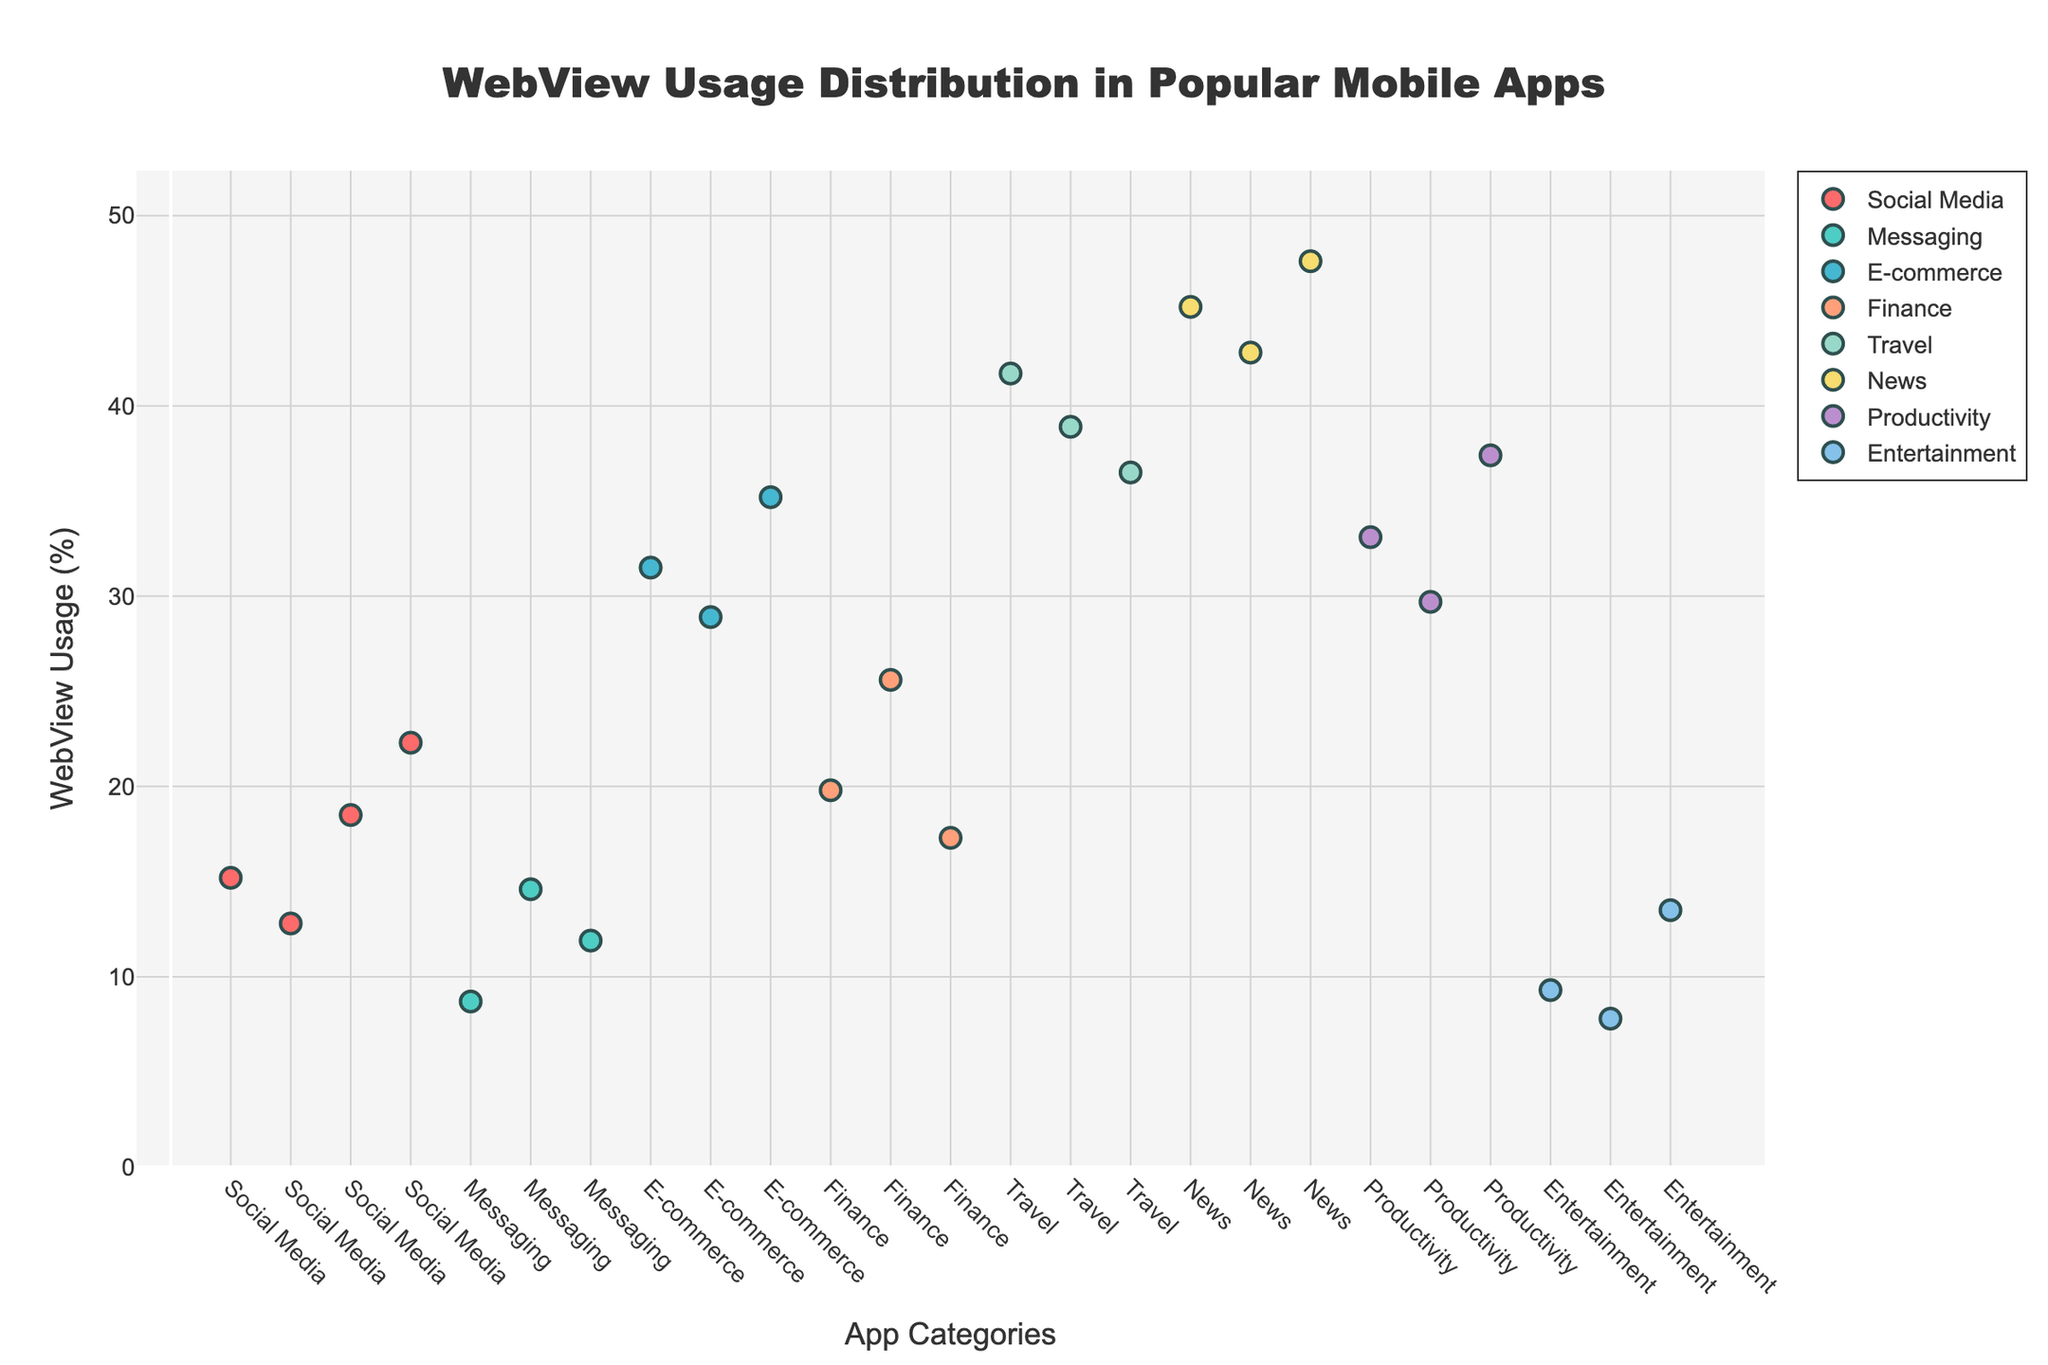What's the title of the plot? The title is usually displayed at the top of the plot. In this case, it reads "WebView Usage Distribution in Popular Mobile Apps".
Answer: WebView Usage Distribution in Popular Mobile Apps What is the y-axis representing? The y-axis represents "WebView Usage (%)", indicating the percentage of WebView usage among the apps. This can be deduced from the y-axis label.
Answer: WebView Usage (%) Which app has the highest WebView usage percentage? By observing the highest point on the y-axis, you can identify that "The New York Times" has the highest WebView usage percentage at 47.6%.
Answer: The New York Times How many app categories are represented in the plot? Each category is uniquely color-coded and listed in the legend. By counting the number of distinct colors and legend entries, we find there are 7 categories.
Answer: 7 Which category, on average, has the highest WebView usage? To find the average for each category, sum the WebView usage percentages within each category and divide by the number of apps in that category. Compare these averages to find the highest one. News Category: (45.2 + 42.8 + 47.6)/3 = 45.2. Travel Category: (41.7 + 38.9 + 36.5)/3 = 39.03. E-commerce Category: (31.5 + 28.9 + 35.2)/3 = 31.87. Productivity Category: (33.1 + 29.7 + 37.4)/3 = 33.4. Finance Category: (19.8 + 25.6 + 17.3)/3 = 20.9. Social Media Category: (15.2 + 12.8 + 18.5 + 22.3)/4 = 17.2. Messaging Category: (8.7 + 14.6 + 11.9)/3 = 11.73. Entertainment Category: (9.3 + 7.8 + 13.5)/3 = 10.2. The News category has the highest average.
Answer: News What is the difference in WebView usage percentage between Facebook and Twitter? Identify the WebView usage percentages for Facebook (15.2%) and Twitter (18.5%). Calculate the difference: 18.5% - 15.2% = 3.3%.
Answer: 3.3% Which two apps within the Social Media category have the largest difference in WebView usage? Compare the WebView usage percentages within the Social Media category. The largest difference is between LinkedIn (22.3%) and Instagram (12.8%): 22.3% - 12.8% = 9.5%.
Answer: LinkedIn and Instagram How does the WebView usage of Netflix (Entertainment category) compare to that of Amazon (E-commerce category)? Netflix has a WebView usage of 9.3% and Amazon has 31.5%. The comparison indicates that Amazon has a higher WebView usage percentage than Netflix.
Answer: Amazon is higher Which category has the lowest average WebView usage and what is that average? Calculate the average WebView usage for each category and then find the minimum average. Entertainment Category: (9.3 + 7.8 + 13.5)/3 = 10.2%. Messaging Category: (8.7 + 14.6 + 11.9)/3 = 11.73%. The lowest average is for the Entertainment category at 10.2%.
Answer: Entertainment with 10.2% What's the median WebView usage percentage in the News category? Arrange the WebView percentages for the News category (45.2, 42.8, and 47.6). The median is the middle value, which is 45.2%.
Answer: 45.2% 